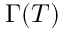<formula> <loc_0><loc_0><loc_500><loc_500>\Gamma ( T )</formula> 